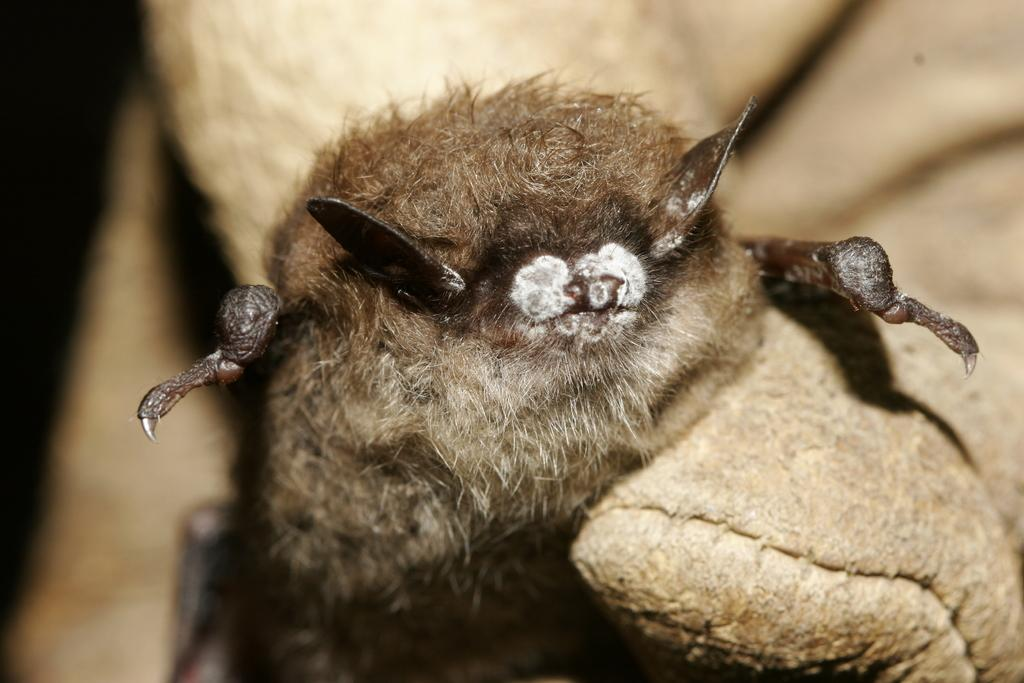What is the main subject of the picture? The main subject of the picture is an insect. Where is the insect located in the picture? The insect is in the middle of the picture. What color is the insect? The insect is brown in color. Can you describe the background of the image? The background of the image is blurred. What type of knot is being tied by the insect in the image? There is no knot or any indication of tying in the image; it features an insect that is brown in color and located in the middle of the picture. How is the coal being used by the insect in the image? There is no coal present in the image; it only features an insect and a blurred background. 